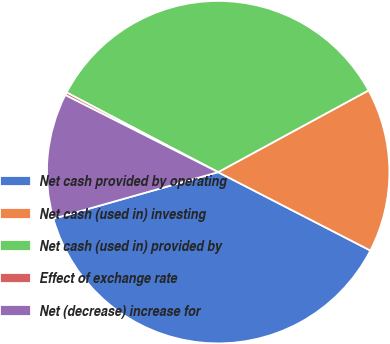Convert chart to OTSL. <chart><loc_0><loc_0><loc_500><loc_500><pie_chart><fcel>Net cash provided by operating<fcel>Net cash (used in) investing<fcel>Net cash (used in) provided by<fcel>Effect of exchange rate<fcel>Net (decrease) increase for<nl><fcel>38.05%<fcel>15.49%<fcel>34.37%<fcel>0.27%<fcel>11.82%<nl></chart> 